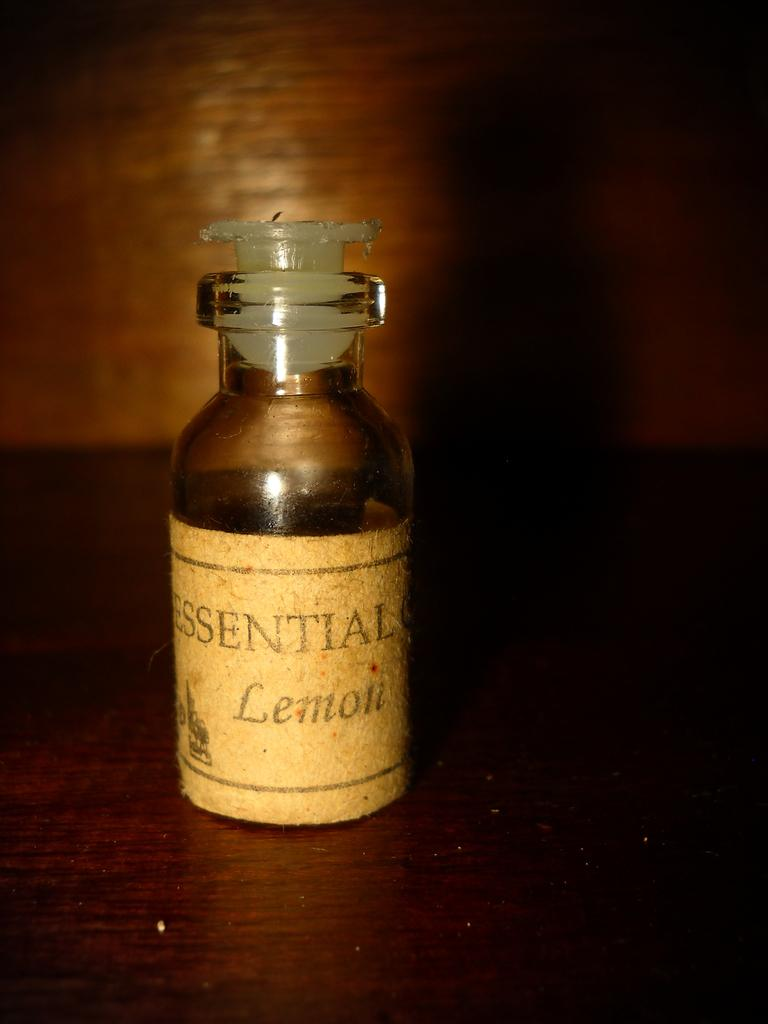<image>
Render a clear and concise summary of the photo. A bottle of Essential Lemon in a vial on a dark wooden shelf. 